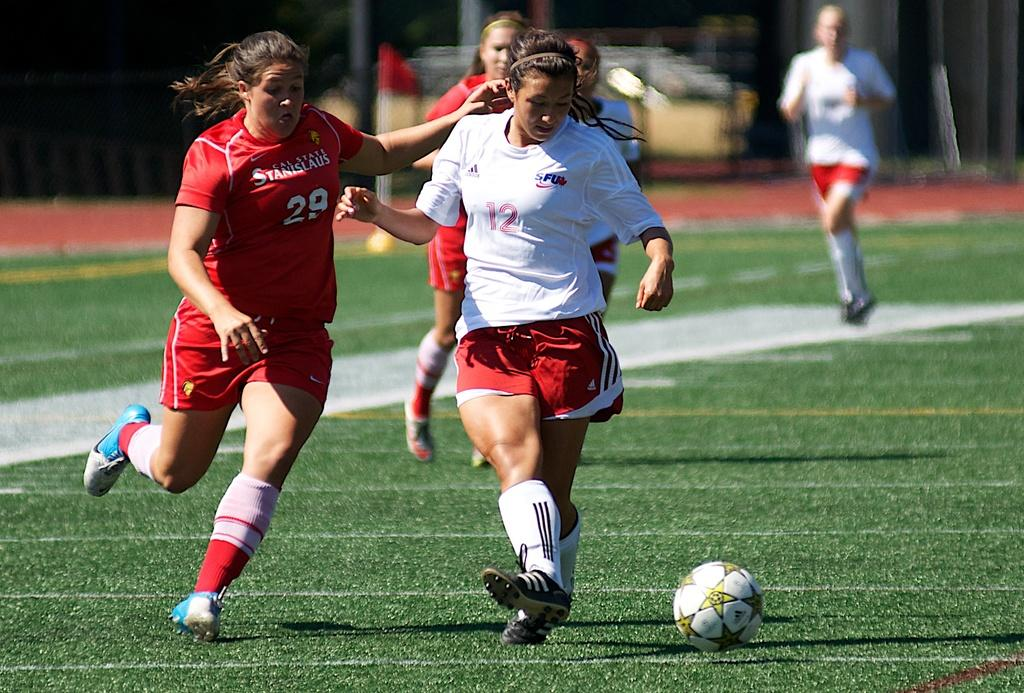<image>
Offer a succinct explanation of the picture presented. Soccer players going for a ball with one wearing a number 12 on her jersey. 